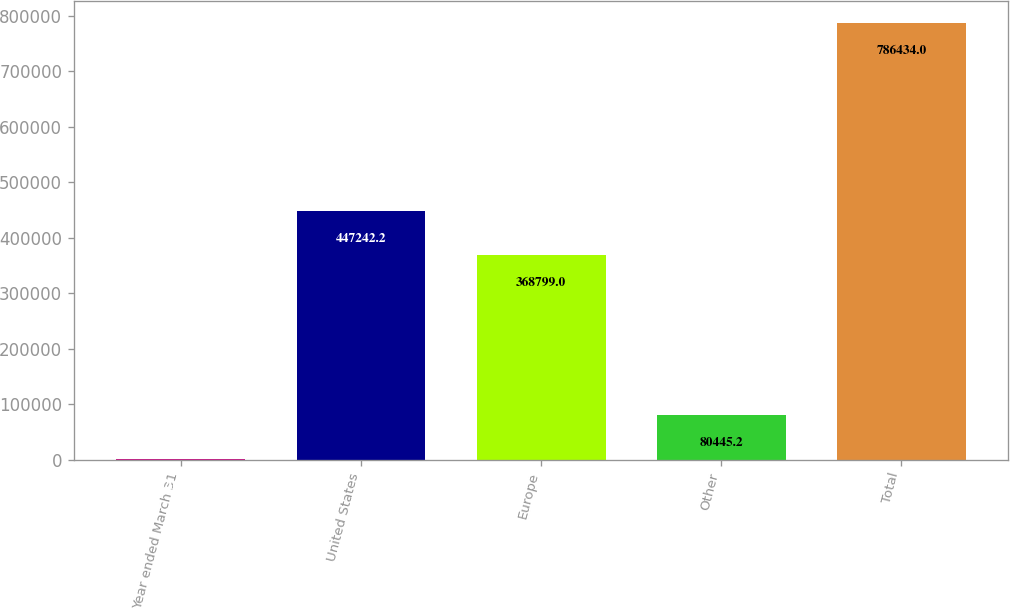Convert chart. <chart><loc_0><loc_0><loc_500><loc_500><bar_chart><fcel>Year ended March 31<fcel>United States<fcel>Europe<fcel>Other<fcel>Total<nl><fcel>2002<fcel>447242<fcel>368799<fcel>80445.2<fcel>786434<nl></chart> 